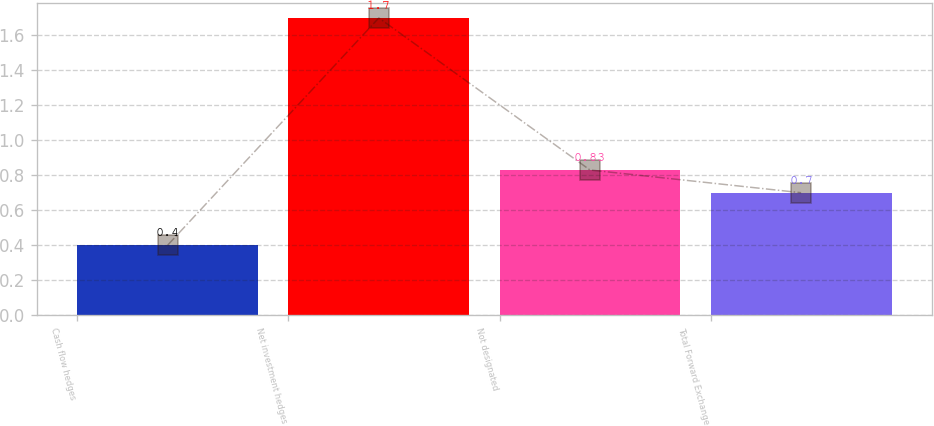Convert chart. <chart><loc_0><loc_0><loc_500><loc_500><bar_chart><fcel>Cash flow hedges<fcel>Net investment hedges<fcel>Not designated<fcel>Total Forward Exchange<nl><fcel>0.4<fcel>1.7<fcel>0.83<fcel>0.7<nl></chart> 